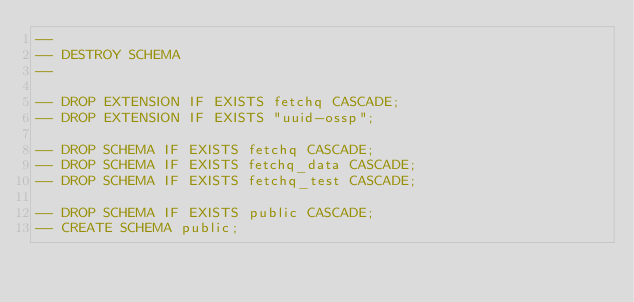Convert code to text. <code><loc_0><loc_0><loc_500><loc_500><_SQL_>--
-- DESTROY SCHEMA
--

-- DROP EXTENSION IF EXISTS fetchq CASCADE;
-- DROP EXTENSION IF EXISTS "uuid-ossp";

-- DROP SCHEMA IF EXISTS fetchq CASCADE;
-- DROP SCHEMA IF EXISTS fetchq_data CASCADE;
-- DROP SCHEMA IF EXISTS fetchq_test CASCADE;

-- DROP SCHEMA IF EXISTS public CASCADE;
-- CREATE SCHEMA public;



</code> 